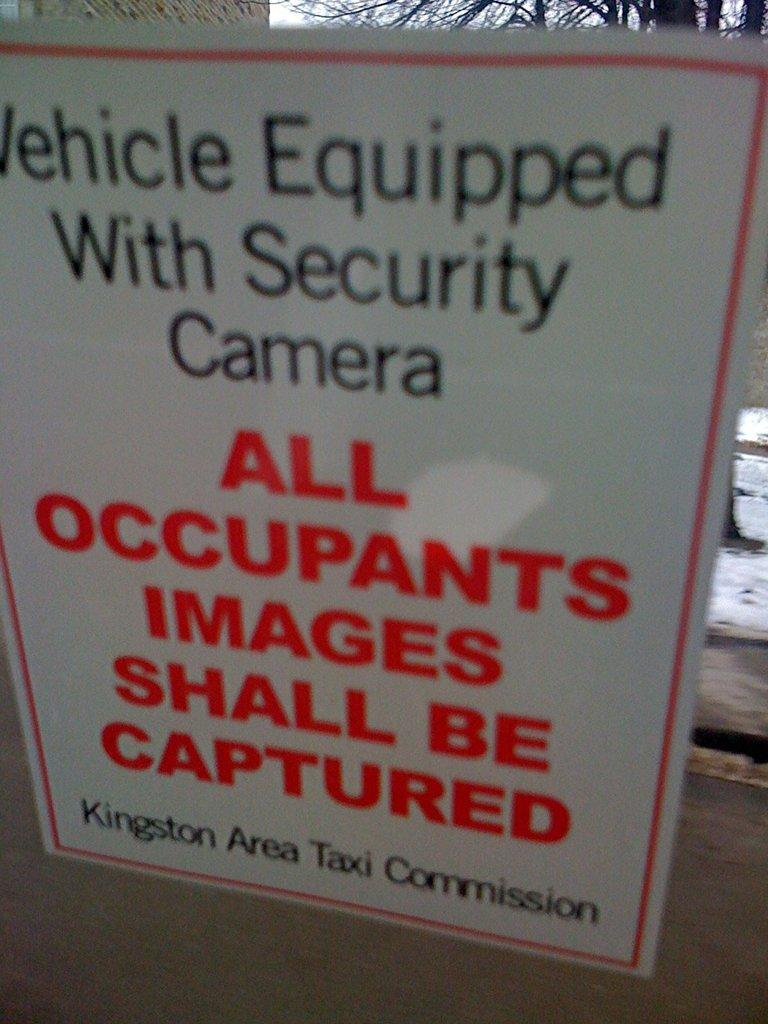What is on the glass in the image? There is a poster on the glass. What can be seen in the background of the image? There is a tree and the sky visible in the background of the image. What color is the object in the background of the image? The object in the background of the image is white. What type of jewel is hanging from the tree in the image? There is no jewel hanging from the tree in the image; it only shows a tree and the sky in the background. 